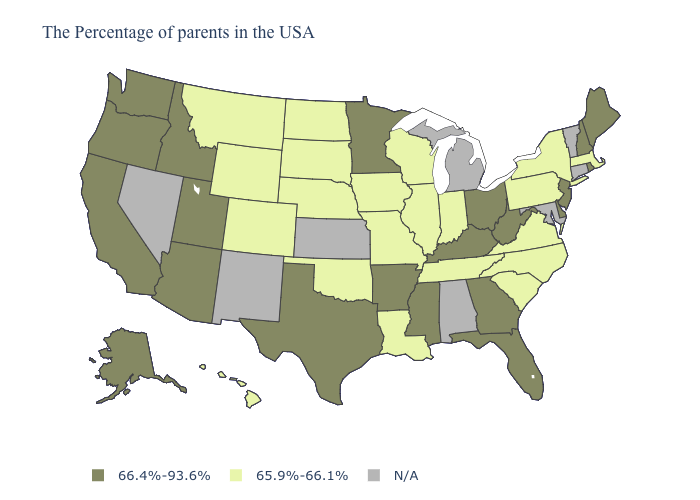What is the lowest value in states that border Idaho?
Keep it brief. 65.9%-66.1%. Does the first symbol in the legend represent the smallest category?
Answer briefly. No. Is the legend a continuous bar?
Short answer required. No. Name the states that have a value in the range 65.9%-66.1%?
Short answer required. Massachusetts, New York, Pennsylvania, Virginia, North Carolina, South Carolina, Indiana, Tennessee, Wisconsin, Illinois, Louisiana, Missouri, Iowa, Nebraska, Oklahoma, South Dakota, North Dakota, Wyoming, Colorado, Montana, Hawaii. Which states have the lowest value in the MidWest?
Answer briefly. Indiana, Wisconsin, Illinois, Missouri, Iowa, Nebraska, South Dakota, North Dakota. Name the states that have a value in the range N/A?
Write a very short answer. Vermont, Connecticut, Maryland, Michigan, Alabama, Kansas, New Mexico, Nevada. Among the states that border New Mexico , does Colorado have the highest value?
Keep it brief. No. What is the lowest value in the MidWest?
Write a very short answer. 65.9%-66.1%. Name the states that have a value in the range N/A?
Answer briefly. Vermont, Connecticut, Maryland, Michigan, Alabama, Kansas, New Mexico, Nevada. What is the lowest value in the USA?
Answer briefly. 65.9%-66.1%. What is the value of Oklahoma?
Keep it brief. 65.9%-66.1%. What is the value of Florida?
Keep it brief. 66.4%-93.6%. Does the first symbol in the legend represent the smallest category?
Give a very brief answer. No. What is the value of Rhode Island?
Answer briefly. 66.4%-93.6%. Name the states that have a value in the range N/A?
Write a very short answer. Vermont, Connecticut, Maryland, Michigan, Alabama, Kansas, New Mexico, Nevada. 